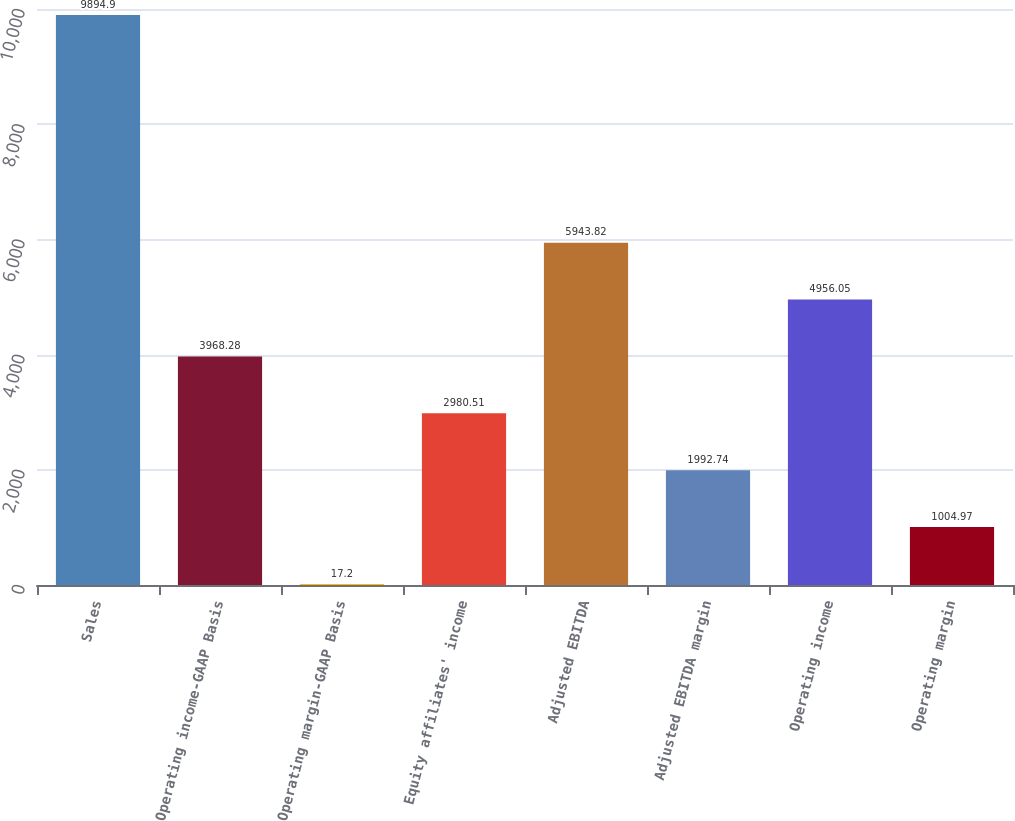Convert chart to OTSL. <chart><loc_0><loc_0><loc_500><loc_500><bar_chart><fcel>Sales<fcel>Operating income-GAAP Basis<fcel>Operating margin-GAAP Basis<fcel>Equity affiliates' income<fcel>Adjusted EBITDA<fcel>Adjusted EBITDA margin<fcel>Operating income<fcel>Operating margin<nl><fcel>9894.9<fcel>3968.28<fcel>17.2<fcel>2980.51<fcel>5943.82<fcel>1992.74<fcel>4956.05<fcel>1004.97<nl></chart> 